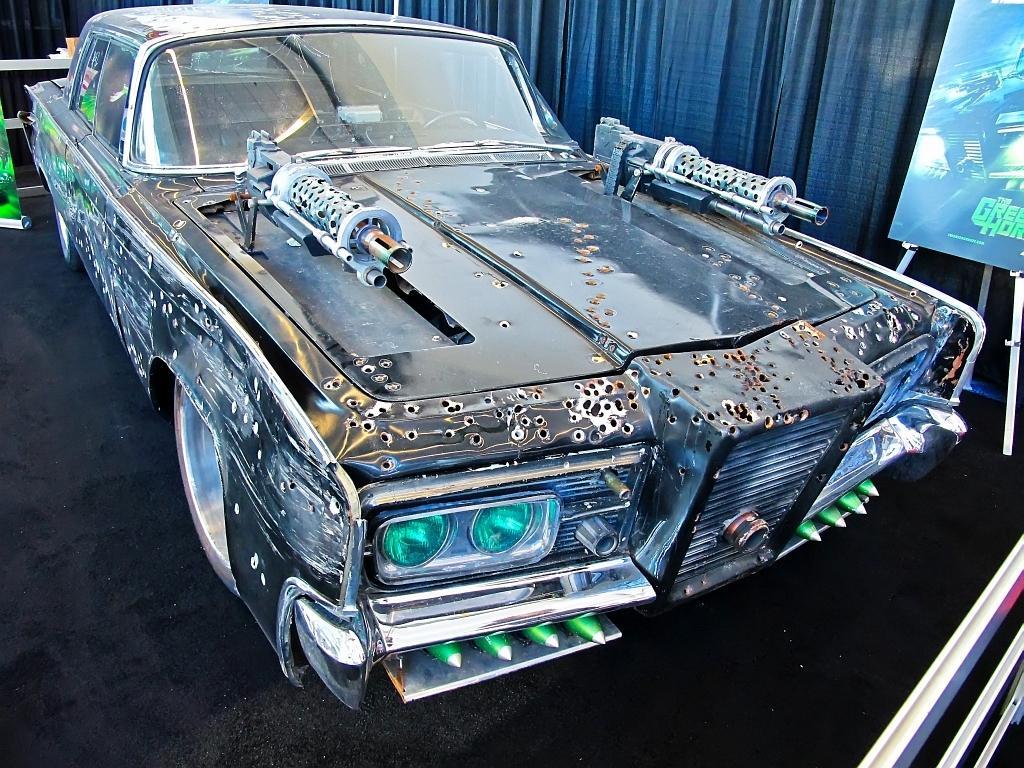Describe this image in one or two sentences. In this picture there is a damaged car in the center of the image and there is a poster on the right side of the image. 